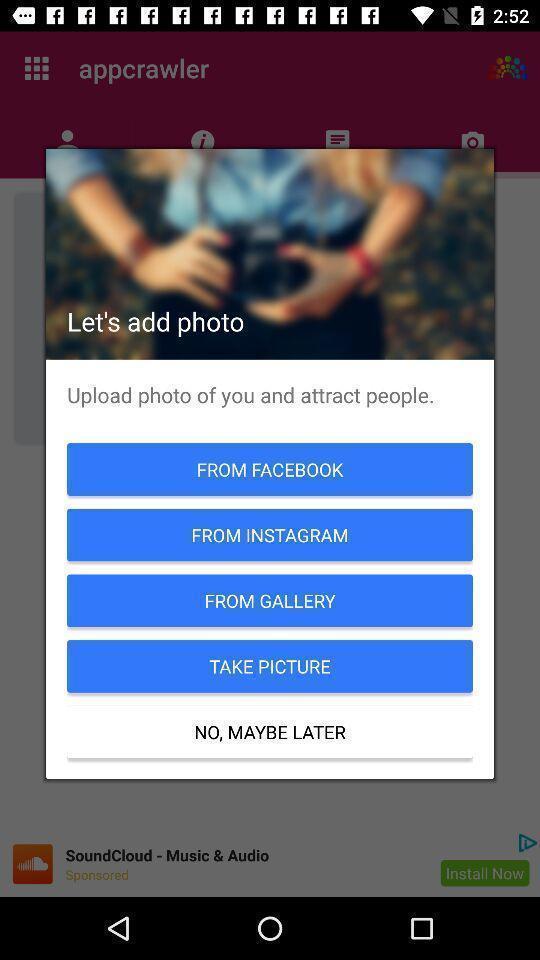Summarize the main components in this picture. Pop-up with options for a dating based app. 